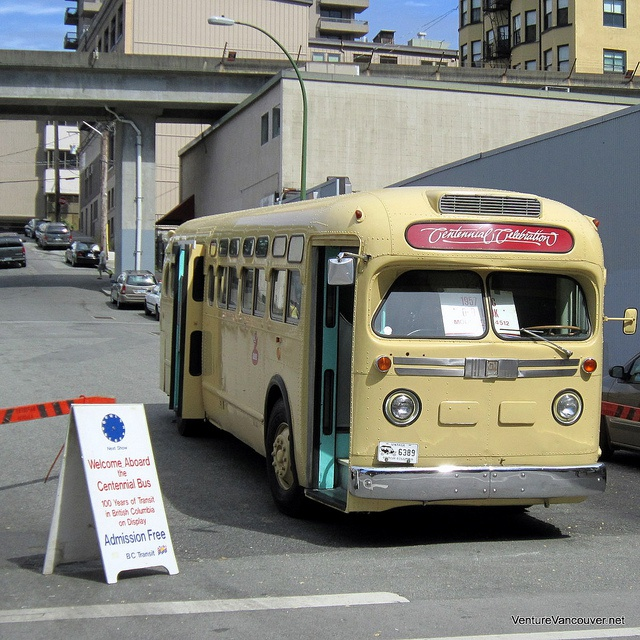Describe the objects in this image and their specific colors. I can see bus in lightblue, black, gray, khaki, and tan tones, car in lightblue, black, gray, maroon, and blue tones, car in lightblue, gray, darkgray, and black tones, car in lightblue, gray, black, and darkgray tones, and car in lightblue, black, gray, and darkgray tones in this image. 